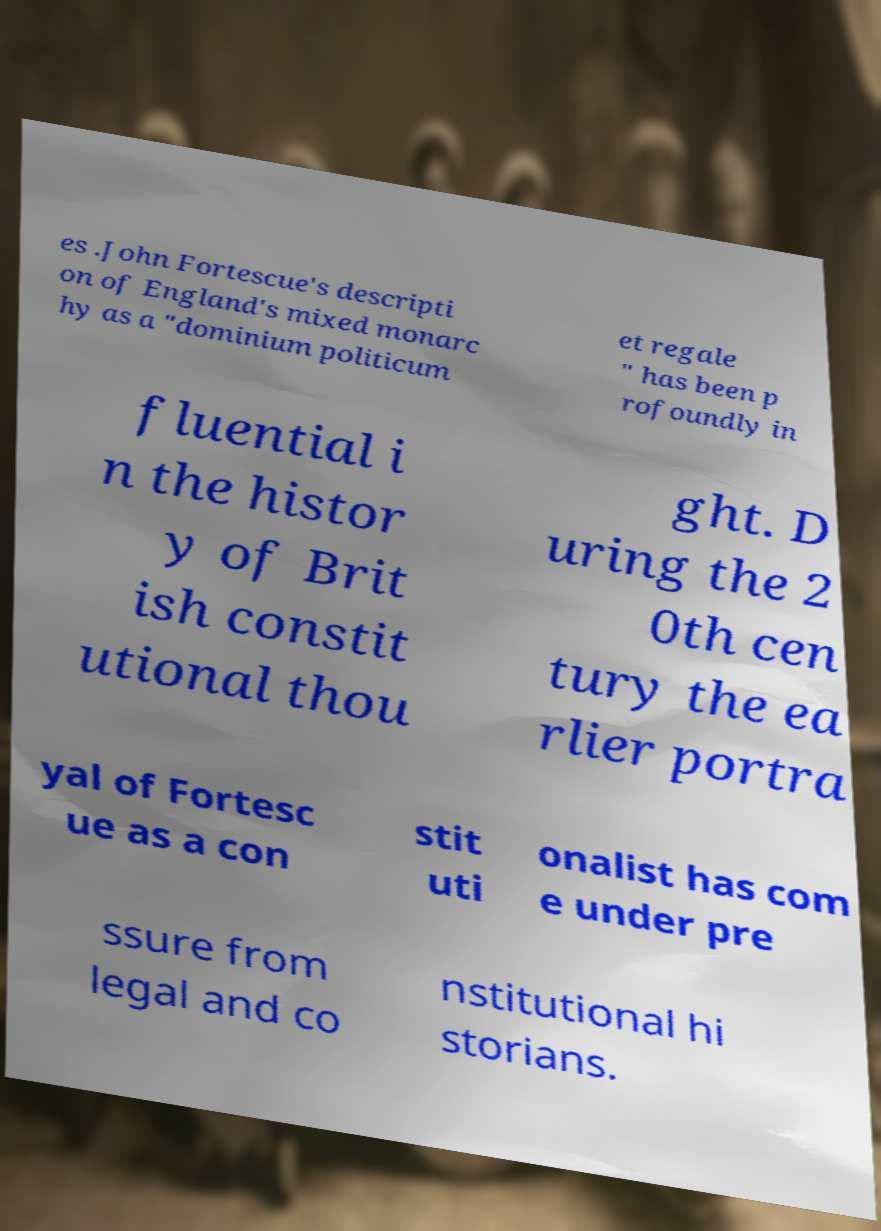What messages or text are displayed in this image? I need them in a readable, typed format. es .John Fortescue's descripti on of England's mixed monarc hy as a "dominium politicum et regale " has been p rofoundly in fluential i n the histor y of Brit ish constit utional thou ght. D uring the 2 0th cen tury the ea rlier portra yal of Fortesc ue as a con stit uti onalist has com e under pre ssure from legal and co nstitutional hi storians. 